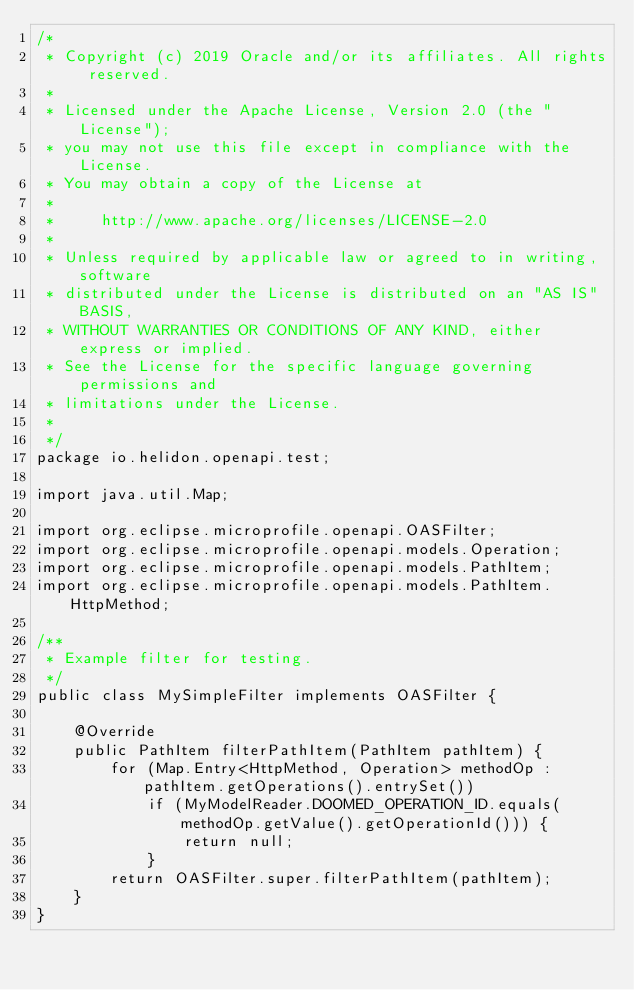Convert code to text. <code><loc_0><loc_0><loc_500><loc_500><_Java_>/*
 * Copyright (c) 2019 Oracle and/or its affiliates. All rights reserved.
 *
 * Licensed under the Apache License, Version 2.0 (the "License");
 * you may not use this file except in compliance with the License.
 * You may obtain a copy of the License at
 *
 *     http://www.apache.org/licenses/LICENSE-2.0
 *
 * Unless required by applicable law or agreed to in writing, software
 * distributed under the License is distributed on an "AS IS" BASIS,
 * WITHOUT WARRANTIES OR CONDITIONS OF ANY KIND, either express or implied.
 * See the License for the specific language governing permissions and
 * limitations under the License.
 *
 */
package io.helidon.openapi.test;

import java.util.Map;

import org.eclipse.microprofile.openapi.OASFilter;
import org.eclipse.microprofile.openapi.models.Operation;
import org.eclipse.microprofile.openapi.models.PathItem;
import org.eclipse.microprofile.openapi.models.PathItem.HttpMethod;

/**
 * Example filter for testing.
 */
public class MySimpleFilter implements OASFilter {

    @Override
    public PathItem filterPathItem(PathItem pathItem) {
        for (Map.Entry<HttpMethod, Operation> methodOp : pathItem.getOperations().entrySet())
            if (MyModelReader.DOOMED_OPERATION_ID.equals(methodOp.getValue().getOperationId())) {
                return null;
            }
        return OASFilter.super.filterPathItem(pathItem);
    }
}
</code> 